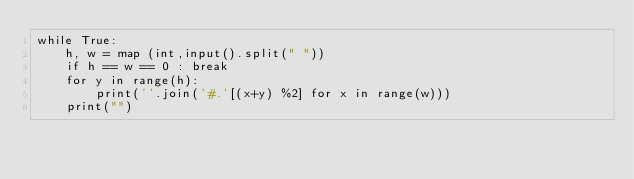<code> <loc_0><loc_0><loc_500><loc_500><_Python_>while True:
    h, w = map (int,input().split(" "))
    if h == w == 0 : break
    for y in range(h):
        print(''.join('#.'[(x+y) %2] for x in range(w)))
    print("")</code> 